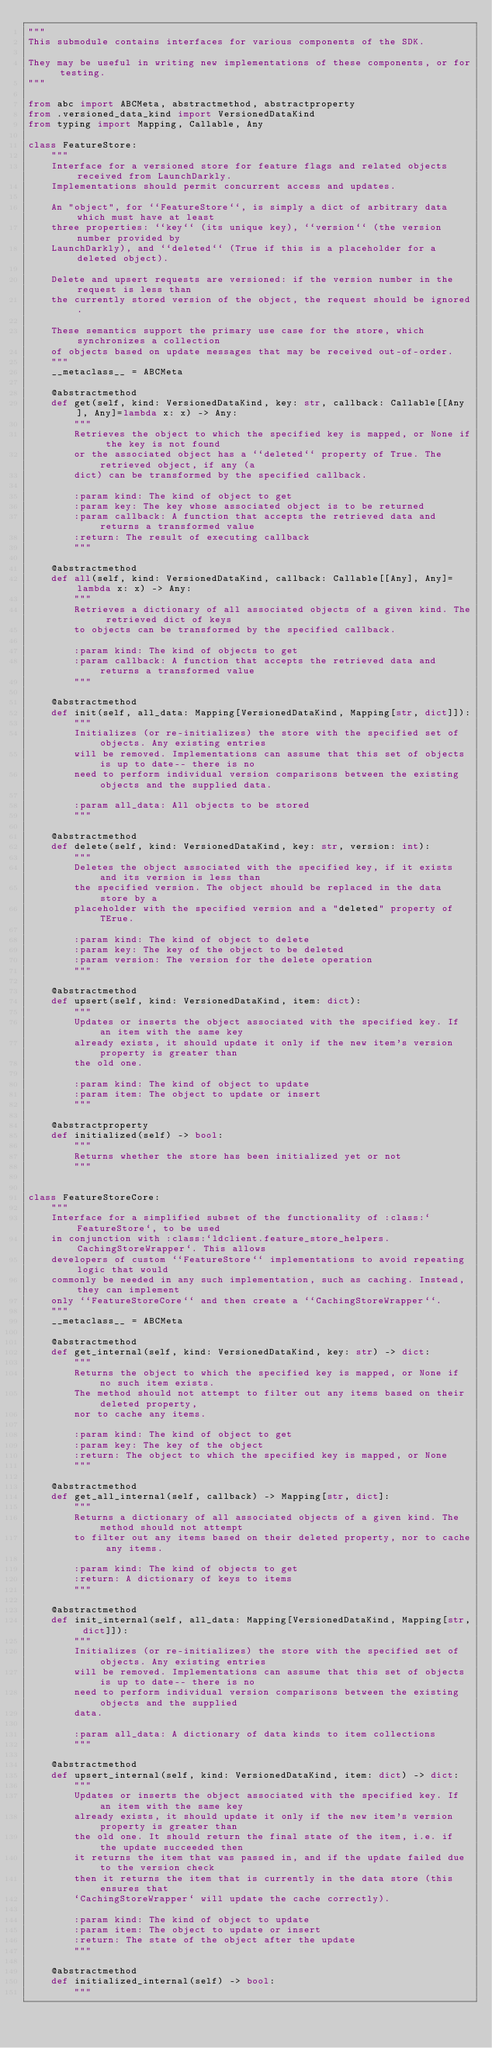<code> <loc_0><loc_0><loc_500><loc_500><_Python_>"""
This submodule contains interfaces for various components of the SDK.

They may be useful in writing new implementations of these components, or for testing.
"""

from abc import ABCMeta, abstractmethod, abstractproperty
from .versioned_data_kind import VersionedDataKind
from typing import Mapping, Callable, Any

class FeatureStore:
    """
    Interface for a versioned store for feature flags and related objects received from LaunchDarkly.
    Implementations should permit concurrent access and updates.

    An "object", for ``FeatureStore``, is simply a dict of arbitrary data which must have at least
    three properties: ``key`` (its unique key), ``version`` (the version number provided by
    LaunchDarkly), and ``deleted`` (True if this is a placeholder for a deleted object).

    Delete and upsert requests are versioned: if the version number in the request is less than
    the currently stored version of the object, the request should be ignored.

    These semantics support the primary use case for the store, which synchronizes a collection
    of objects based on update messages that may be received out-of-order.
    """
    __metaclass__ = ABCMeta

    @abstractmethod
    def get(self, kind: VersionedDataKind, key: str, callback: Callable[[Any], Any]=lambda x: x) -> Any:
        """
        Retrieves the object to which the specified key is mapped, or None if the key is not found
        or the associated object has a ``deleted`` property of True. The retrieved object, if any (a
        dict) can be transformed by the specified callback.

        :param kind: The kind of object to get
        :param key: The key whose associated object is to be returned
        :param callback: A function that accepts the retrieved data and returns a transformed value
        :return: The result of executing callback
        """

    @abstractmethod
    def all(self, kind: VersionedDataKind, callback: Callable[[Any], Any]=lambda x: x) -> Any:
        """
        Retrieves a dictionary of all associated objects of a given kind. The retrieved dict of keys
        to objects can be transformed by the specified callback.

        :param kind: The kind of objects to get
        :param callback: A function that accepts the retrieved data and returns a transformed value
        """

    @abstractmethod
    def init(self, all_data: Mapping[VersionedDataKind, Mapping[str, dict]]):
        """
        Initializes (or re-initializes) the store with the specified set of objects. Any existing entries
        will be removed. Implementations can assume that this set of objects is up to date-- there is no
        need to perform individual version comparisons between the existing objects and the supplied data.

        :param all_data: All objects to be stored
        """

    @abstractmethod
    def delete(self, kind: VersionedDataKind, key: str, version: int):
        """
        Deletes the object associated with the specified key, if it exists and its version is less than
        the specified version. The object should be replaced in the data store by a
        placeholder with the specified version and a "deleted" property of TErue.

        :param kind: The kind of object to delete
        :param key: The key of the object to be deleted
        :param version: The version for the delete operation
        """

    @abstractmethod
    def upsert(self, kind: VersionedDataKind, item: dict):
        """
        Updates or inserts the object associated with the specified key. If an item with the same key
        already exists, it should update it only if the new item's version property is greater than
        the old one.

        :param kind: The kind of object to update
        :param item: The object to update or insert
        """

    @abstractproperty
    def initialized(self) -> bool:
        """
        Returns whether the store has been initialized yet or not
        """


class FeatureStoreCore:
    """
    Interface for a simplified subset of the functionality of :class:`FeatureStore`, to be used
    in conjunction with :class:`ldclient.feature_store_helpers.CachingStoreWrapper`. This allows
    developers of custom ``FeatureStore`` implementations to avoid repeating logic that would
    commonly be needed in any such implementation, such as caching. Instead, they can implement
    only ``FeatureStoreCore`` and then create a ``CachingStoreWrapper``.
    """
    __metaclass__ = ABCMeta

    @abstractmethod
    def get_internal(self, kind: VersionedDataKind, key: str) -> dict:
        """
        Returns the object to which the specified key is mapped, or None if no such item exists.
        The method should not attempt to filter out any items based on their deleted property,
        nor to cache any items.

        :param kind: The kind of object to get
        :param key: The key of the object
        :return: The object to which the specified key is mapped, or None
        """

    @abstractmethod
    def get_all_internal(self, callback) -> Mapping[str, dict]:
        """
        Returns a dictionary of all associated objects of a given kind. The method should not attempt
        to filter out any items based on their deleted property, nor to cache any items.

        :param kind: The kind of objects to get
        :return: A dictionary of keys to items
        """

    @abstractmethod
    def init_internal(self, all_data: Mapping[VersionedDataKind, Mapping[str, dict]]):
        """
        Initializes (or re-initializes) the store with the specified set of objects. Any existing entries
        will be removed. Implementations can assume that this set of objects is up to date-- there is no
        need to perform individual version comparisons between the existing objects and the supplied
        data.

        :param all_data: A dictionary of data kinds to item collections
        """

    @abstractmethod
    def upsert_internal(self, kind: VersionedDataKind, item: dict) -> dict:
        """
        Updates or inserts the object associated with the specified key. If an item with the same key
        already exists, it should update it only if the new item's version property is greater than
        the old one. It should return the final state of the item, i.e. if the update succeeded then
        it returns the item that was passed in, and if the update failed due to the version check
        then it returns the item that is currently in the data store (this ensures that
        `CachingStoreWrapper` will update the cache correctly).

        :param kind: The kind of object to update
        :param item: The object to update or insert
        :return: The state of the object after the update
        """

    @abstractmethod
    def initialized_internal(self) -> bool:
        """</code> 